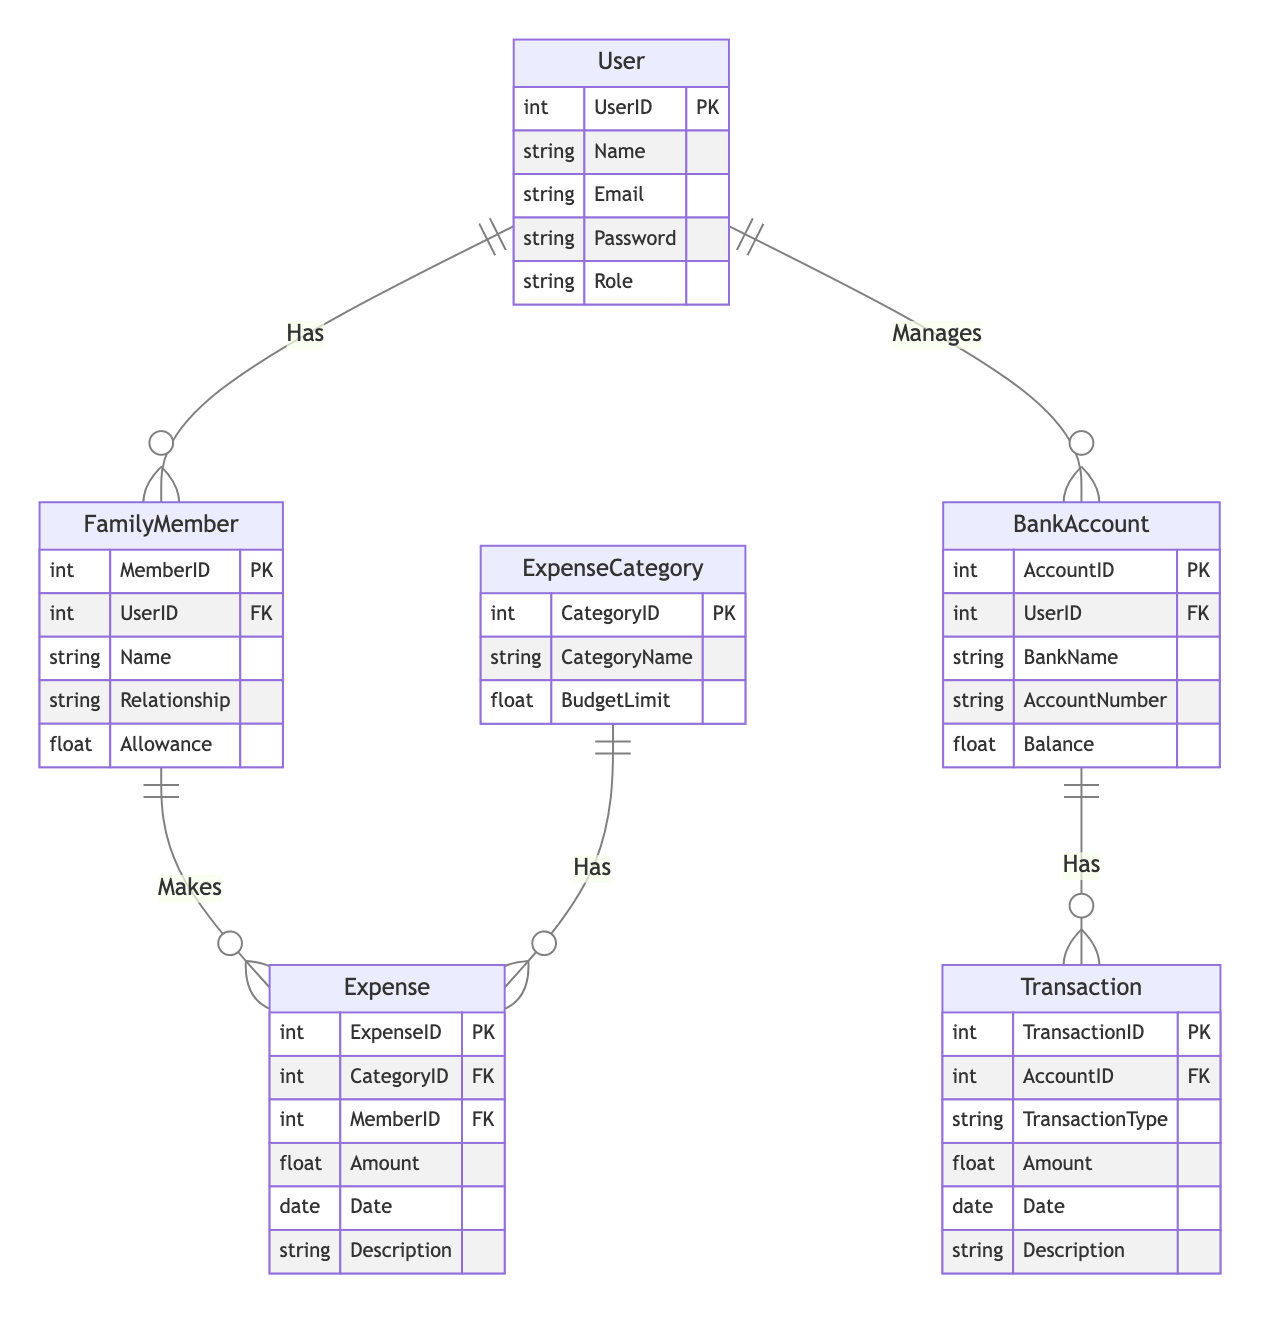What is the primary key of the User entity? The primary key of the User entity is UserID. This can be identified by looking at the attributes listed for the User entity in the diagram, where it is explicitly marked as PK (Primary Key).
Answer: UserID How many relationships are depicted in the diagram? The diagram illustrates five unique relationships between the entities, which can be counted by examining the connections made between the entities, each indicating a relationship.
Answer: Five What type of relationship exists between FamilyMember and Expense? The relationship between FamilyMember and Expense is one-to-many (1:N), indicating that one FamilyMember can make multiple Expenses, as shown by the connecting line in the diagram labeled "Makes".
Answer: One-to-many Which entity has a direct relation with BankAccount? The User entity has a direct one-to-many relationship with the BankAccount entity, as indicated by the relationship line connecting them with the label "Manages".
Answer: User What is the maximum number of FamilyMembers a User can have? A User can have multiple FamilyMembers since the relationship from User to FamilyMember is one-to-many (1:N), allowing for any number of FamilyMembers associated with a single User.
Answer: Many 